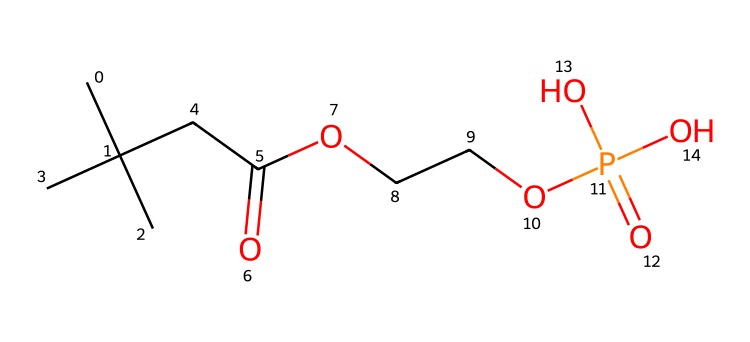What is the molecular formula of the compound? To determine the molecular formula, we need to count the number of each type of atom present in the SMILES representation. The compound consists of 12 carbon atoms, 21 hydrogen atoms, 4 oxygen atoms, and 1 phosphorus atom, leading to the molecular formula C12H21O4P.
Answer: C12H21O4P How many hydroxyl (–OH) groups are present? By examining the structure, we see that there are three –OH groups indicated in the representation (from the three oxygen atoms connected to phosphorus).
Answer: 3 What functional groups are present in this compound? The functional groups can be identified by looking for specific arrangements of atoms. The compound contains a phosphonic acid group (indicated by the P with its relevant O and OH groups) and an ester group (from the O–C linkage). Thus, it is a phosphonic acid ester.
Answer: phosphonic acid and ester Is this compound polar or non-polar? The presence of multiple hydroxyl groups and the polar phosphorus atom indicates that the compound can form hydrogen bonds, making it polar overall. The overall structure suggests a hydrophilic character due to these functional groups.
Answer: polar What is the significance of the phosphorus atom in the compound? The phosphorus atom is central to phosphonic acids and imparts antimicrobial properties. It allows the compound to interact with microbial membranes, leading to potential antimicrobial activity, especially important in healthcare wearables.
Answer: antimicrobial properties How many total atoms are in the compound? To find the total number of atoms, we add the number of each atom: 12 (C) + 21 (H) + 4 (O) + 1 (P) = 38 atoms in total. Therefore, the total atom count is 38.
Answer: 38 